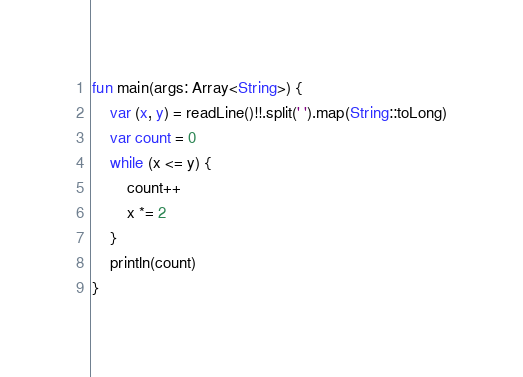<code> <loc_0><loc_0><loc_500><loc_500><_Kotlin_>fun main(args: Array<String>) {
    var (x, y) = readLine()!!.split(' ').map(String::toLong)
    var count = 0
    while (x <= y) {
        count++
        x *= 2
    }
    println(count)
}</code> 